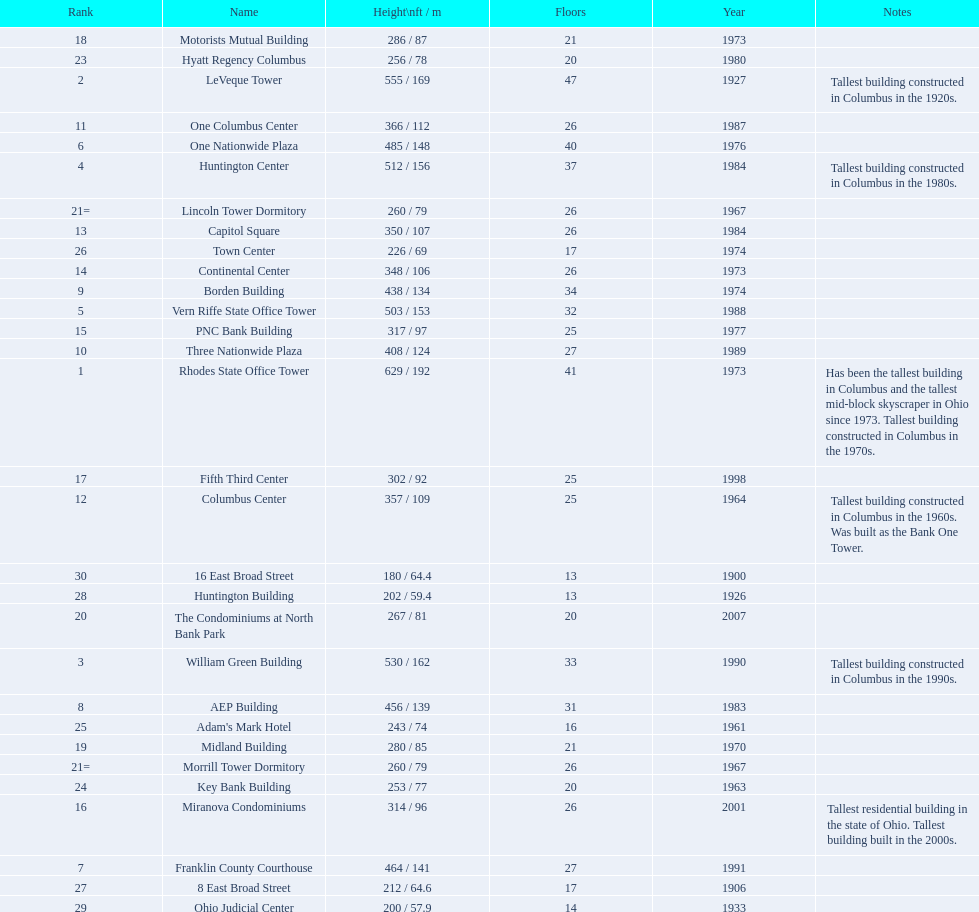Which of the tallest buildings in columbus, ohio were built in the 1980s? Huntington Center, Vern Riffe State Office Tower, AEP Building, Three Nationwide Plaza, One Columbus Center, Capitol Square, Hyatt Regency Columbus. Of these buildings, which have between 26 and 31 floors? AEP Building, Three Nationwide Plaza, One Columbus Center, Capitol Square. Of these buildings, which is the tallest? AEP Building. 